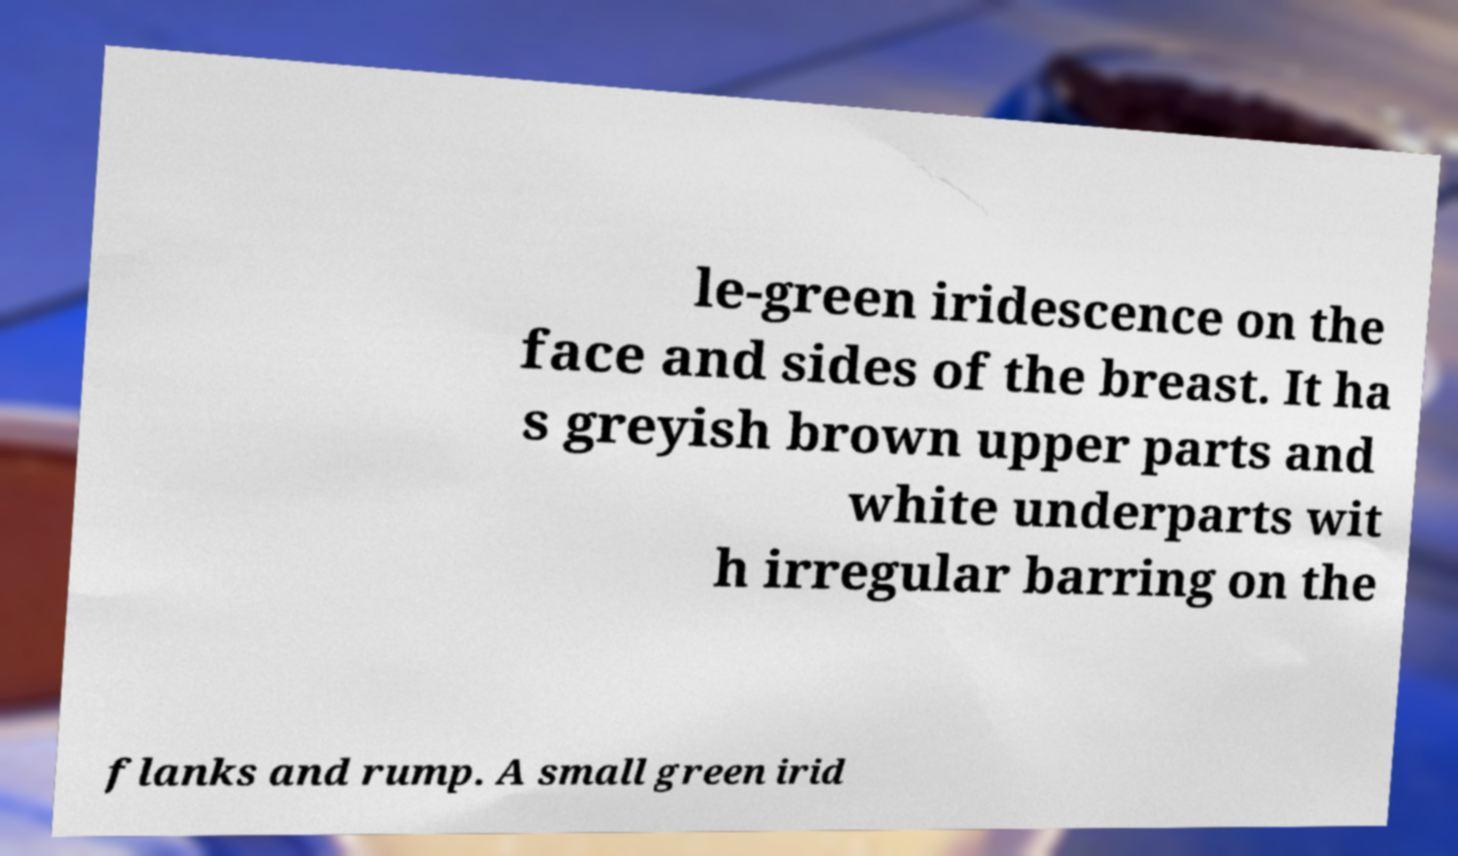Could you extract and type out the text from this image? le-green iridescence on the face and sides of the breast. It ha s greyish brown upper parts and white underparts wit h irregular barring on the flanks and rump. A small green irid 